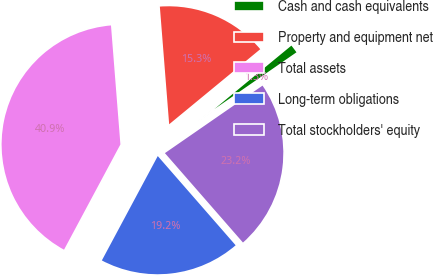<chart> <loc_0><loc_0><loc_500><loc_500><pie_chart><fcel>Cash and cash equivalents<fcel>Property and equipment net<fcel>Total assets<fcel>Long-term obligations<fcel>Total stockholders' equity<nl><fcel>1.34%<fcel>15.29%<fcel>40.92%<fcel>19.25%<fcel>23.21%<nl></chart> 